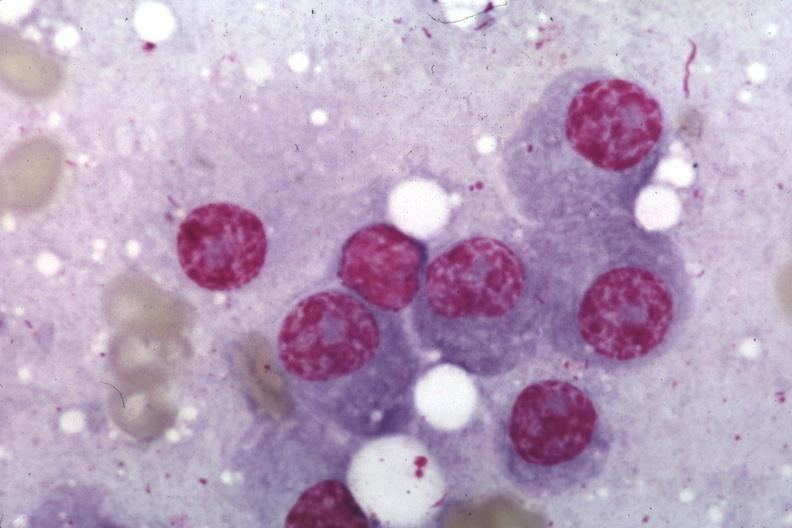s bone marrow present?
Answer the question using a single word or phrase. Yes 